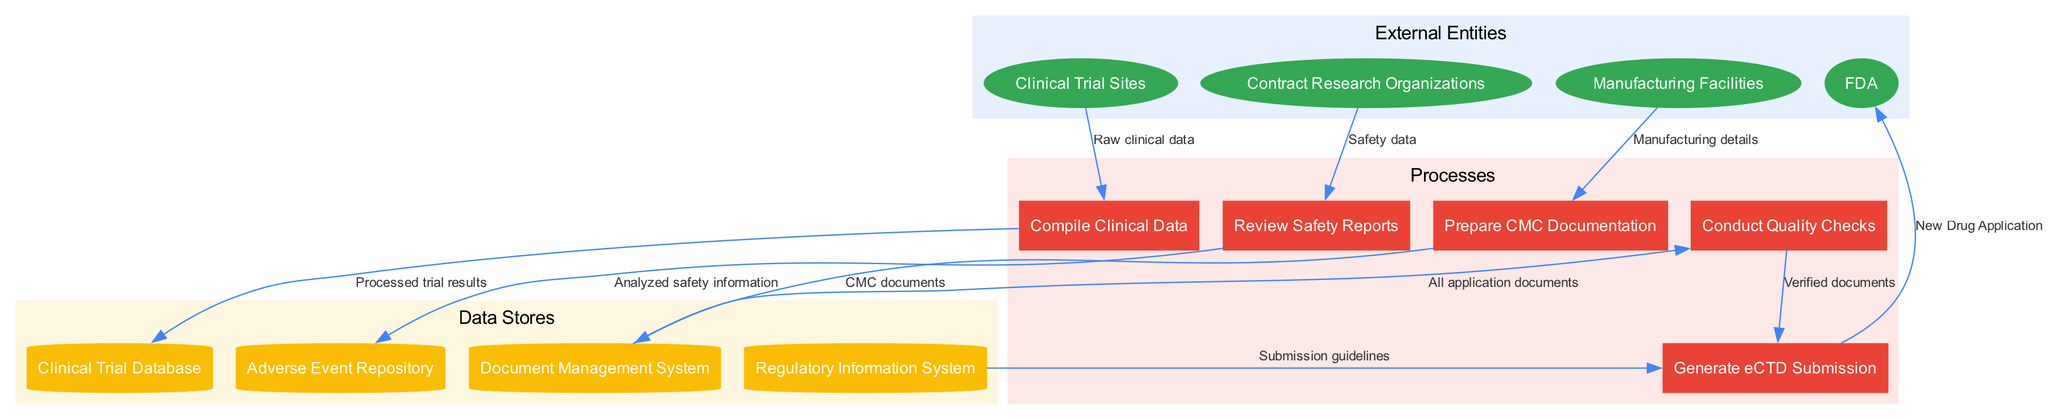What are the external entities in the diagram? The external entities are listed at the top of the diagram, which includes the FDA, Clinical Trial Sites, Contract Research Organizations, and Manufacturing Facilities.
Answer: FDA, Clinical Trial Sites, Contract Research Organizations, Manufacturing Facilities How many processes are there in the diagram? The number of processes can be counted directly from the processes section of the diagram. There are five distinct processes: Compile Clinical Data, Review Safety Reports, Prepare CMC Documentation, Conduct Quality Checks, and Generate eCTD Submission.
Answer: 5 What type of documentation is generated after quality checks? The flow from Conduct Quality Checks to Generate eCTD Submission indicates that the output is verified documents, which means that after quality checks, verified documents are generated to proceed with the eCTD submission.
Answer: Verified documents Which process receives raw clinical data? The data flow from Clinical Trial Sites clearly indicates that the raw clinical data is directed to the Compile Clinical Data process, making it the initial step where raw clinical data is used.
Answer: Compile Clinical Data What data store is associated with safety reports? Analyzing the flow, the Review Safety Reports process leads to the Adverse Event Repository, which signifies that the safety reports are stored here after analysis.
Answer: Adverse Event Repository How many data flows originate from the Manufacturing Facilities? By examining the data flows connected to the Manufacturing Facilities, it can be determined that only one flow originates from it, which is directed towards the Prepare CMC Documentation process.
Answer: 1 What information is sent to the Generate eCTD Submission process? The Generate eCTD Submission process receives verified documents from Conduct Quality Checks and also submission guidelines from the Regulatory Information System, indicating it aggregates multiple sources of information.
Answer: Verified documents, Submission guidelines Which external entity is the final recipient of the new drug application? The data flow from Generate eCTD Submission to FDA specifies that the FDA is the final recipient of the New Drug Application, concluding the process cycle.
Answer: FDA How are processed trial results stored? The flow from Compile Clinical Data to the Clinical Trial Database indicates that processed trial results from this process are stored in the Clinical Trial Database for further reference or use in the application.
Answer: Clinical Trial Database 